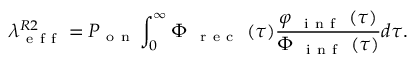<formula> <loc_0><loc_0><loc_500><loc_500>\lambda _ { e f f } ^ { R 2 } = P _ { o n } \int _ { 0 } ^ { \infty } \Phi _ { \mathrm { r e c } } ( \tau ) \frac { \varphi _ { \mathrm { i n f } } ( \tau ) } { \Phi _ { \mathrm { i n f } } ( \tau ) } d \tau .</formula> 